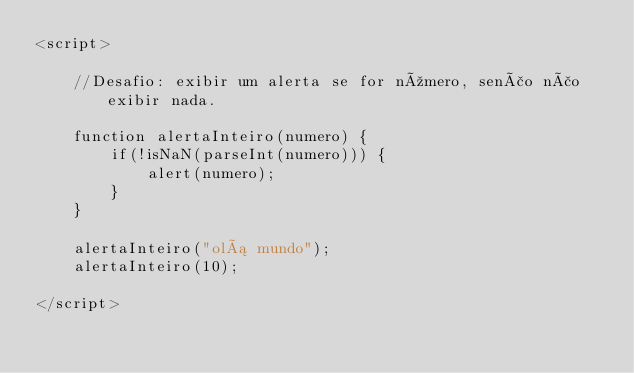<code> <loc_0><loc_0><loc_500><loc_500><_HTML_><script>
	
	//Desafio: exibir um alerta se for número, senão não exibir nada.

	function alertaInteiro(numero) {
		if(!isNaN(parseInt(numero))) {
			alert(numero);
		}
	}

	alertaInteiro("olá mundo");
	alertaInteiro(10);

</script></code> 